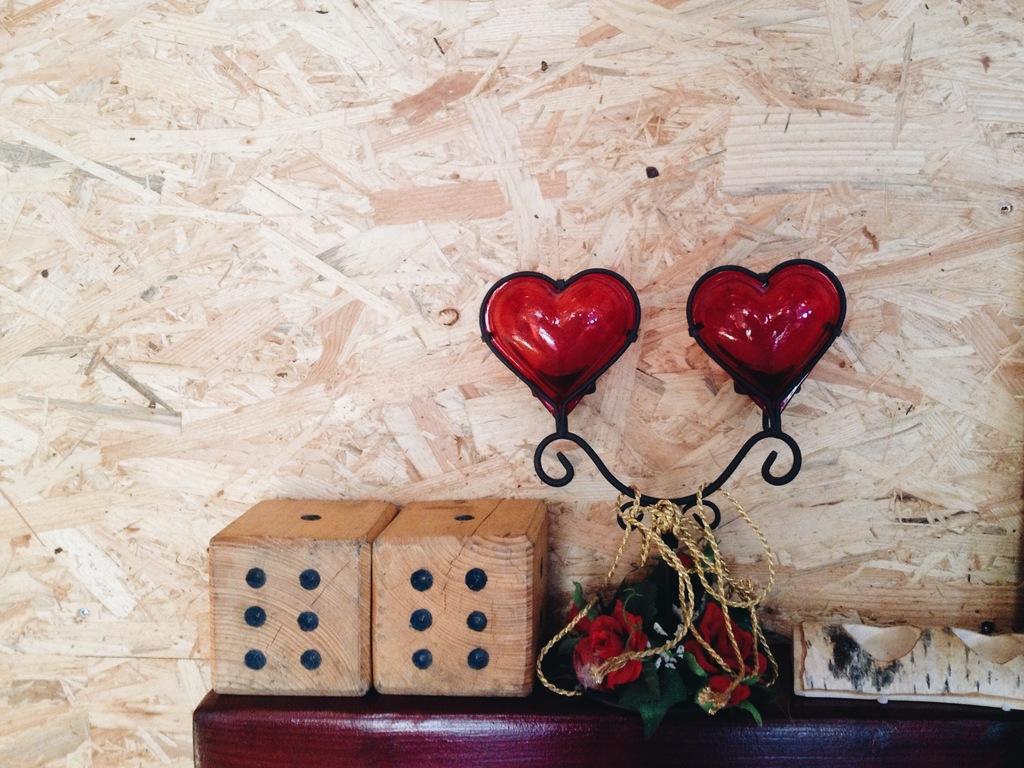How would you summarize this image in a sentence or two? The picture consists of a desk, on the desk there are dices, flowers, wooden object and face. In the picture there is wall. 